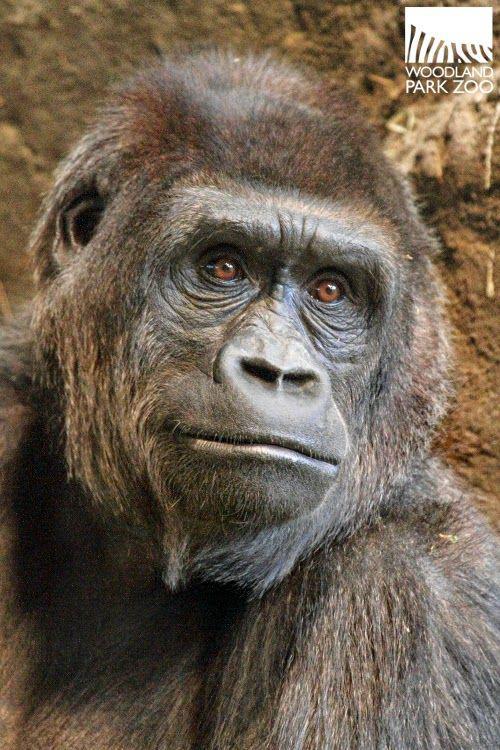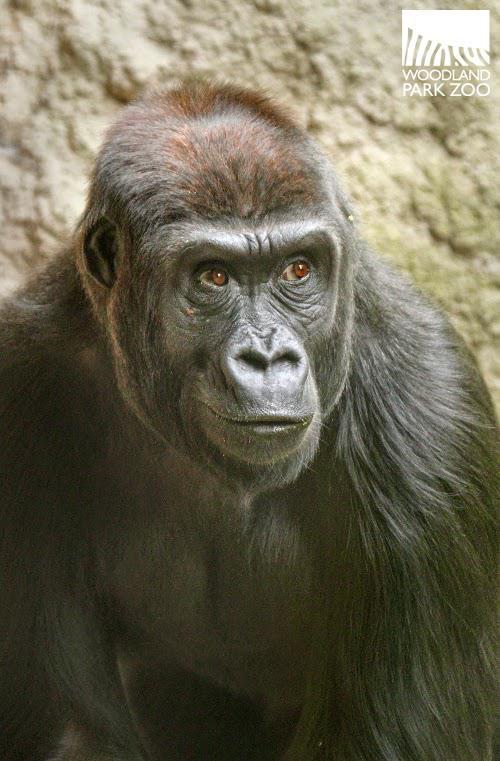The first image is the image on the left, the second image is the image on the right. Examine the images to the left and right. Is the description "One image shows an adult gorilla cradling a baby gorilla at its chest with at least one arm." accurate? Answer yes or no. No. The first image is the image on the left, the second image is the image on the right. Examine the images to the left and right. Is the description "In at least one image there are two gorilla one adult holding a single baby." accurate? Answer yes or no. No. 